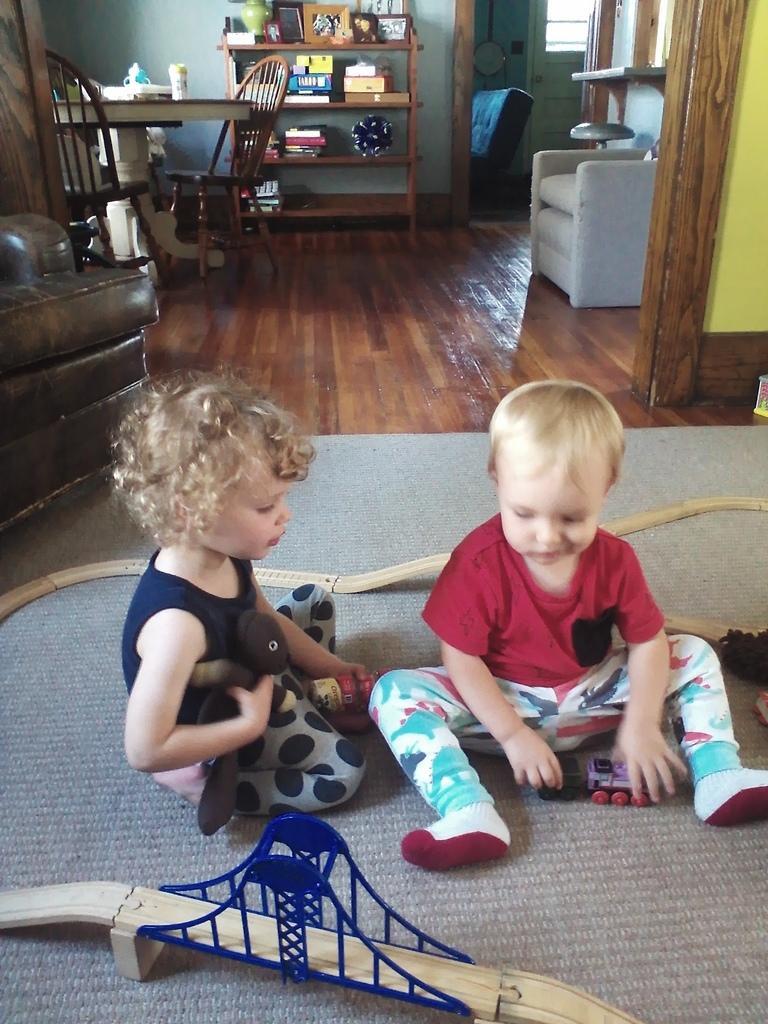Could you give a brief overview of what you see in this image? This is the picture of a place where we have sitting in front of something, behind there is a table on which there are some things and some chairs around and some shelves in which some things are placed and a sofa. 